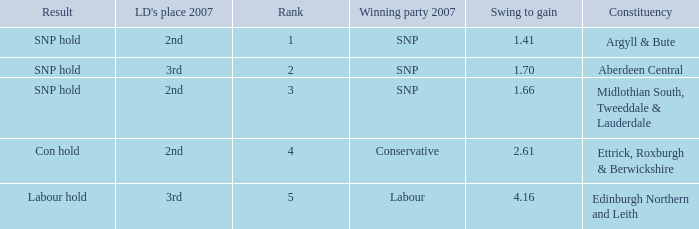Help me parse the entirety of this table. {'header': ['Result', "LD's place 2007", 'Rank', 'Winning party 2007', 'Swing to gain', 'Constituency'], 'rows': [['SNP hold', '2nd', '1', 'SNP', '1.41', 'Argyll & Bute'], ['SNP hold', '3rd', '2', 'SNP', '1.70', 'Aberdeen Central'], ['SNP hold', '2nd', '3', 'SNP', '1.66', 'Midlothian South, Tweeddale & Lauderdale'], ['Con hold', '2nd', '4', 'Conservative', '2.61', 'Ettrick, Roxburgh & Berwickshire'], ['Labour hold', '3rd', '5', 'Labour', '4.16', 'Edinburgh Northern and Leith']]} How many times is the constituency edinburgh northern and leith? 1.0. 